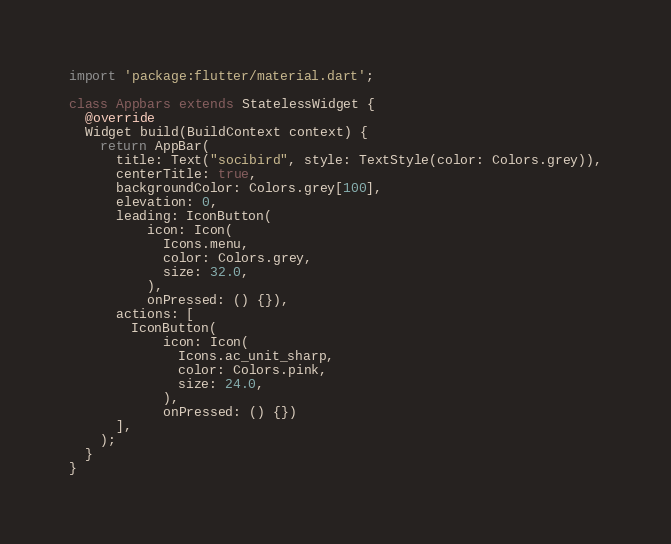Convert code to text. <code><loc_0><loc_0><loc_500><loc_500><_Dart_>import 'package:flutter/material.dart';

class Appbars extends StatelessWidget {
  @override
  Widget build(BuildContext context) {
    return AppBar(
      title: Text("socibird", style: TextStyle(color: Colors.grey)),
      centerTitle: true,
      backgroundColor: Colors.grey[100],
      elevation: 0,
      leading: IconButton(
          icon: Icon(
            Icons.menu,
            color: Colors.grey,
            size: 32.0,
          ),
          onPressed: () {}),
      actions: [
        IconButton(
            icon: Icon(
              Icons.ac_unit_sharp,
              color: Colors.pink,
              size: 24.0,
            ),
            onPressed: () {})
      ],
    );
  }
}
</code> 